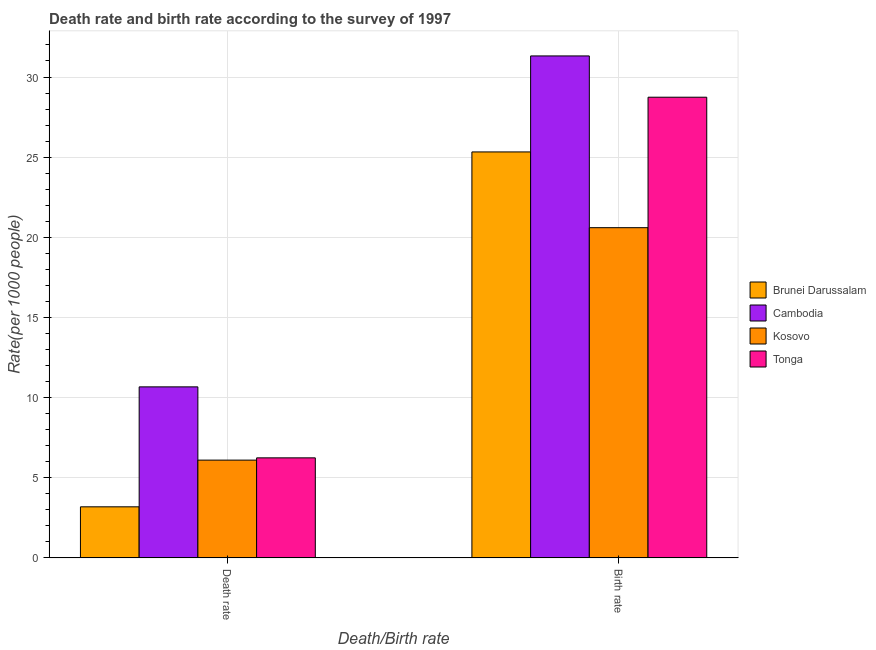Are the number of bars per tick equal to the number of legend labels?
Provide a succinct answer. Yes. What is the label of the 2nd group of bars from the left?
Offer a very short reply. Birth rate. What is the death rate in Brunei Darussalam?
Keep it short and to the point. 3.19. Across all countries, what is the maximum birth rate?
Your answer should be compact. 31.32. Across all countries, what is the minimum death rate?
Your answer should be very brief. 3.19. In which country was the death rate maximum?
Make the answer very short. Cambodia. In which country was the birth rate minimum?
Provide a short and direct response. Kosovo. What is the total death rate in the graph?
Keep it short and to the point. 26.2. What is the difference between the death rate in Tonga and that in Cambodia?
Offer a terse response. -4.43. What is the difference between the death rate in Tonga and the birth rate in Kosovo?
Your answer should be very brief. -14.36. What is the average death rate per country?
Offer a very short reply. 6.55. What is the difference between the death rate and birth rate in Cambodia?
Provide a short and direct response. -20.65. In how many countries, is the death rate greater than 13 ?
Keep it short and to the point. 0. What is the ratio of the birth rate in Cambodia to that in Brunei Darussalam?
Keep it short and to the point. 1.24. Is the birth rate in Kosovo less than that in Cambodia?
Your response must be concise. Yes. In how many countries, is the birth rate greater than the average birth rate taken over all countries?
Make the answer very short. 2. What does the 1st bar from the left in Death rate represents?
Ensure brevity in your answer.  Brunei Darussalam. What does the 3rd bar from the right in Death rate represents?
Give a very brief answer. Cambodia. How many bars are there?
Keep it short and to the point. 8. How many countries are there in the graph?
Your answer should be compact. 4. Does the graph contain any zero values?
Keep it short and to the point. No. Where does the legend appear in the graph?
Offer a very short reply. Center right. How many legend labels are there?
Give a very brief answer. 4. How are the legend labels stacked?
Ensure brevity in your answer.  Vertical. What is the title of the graph?
Keep it short and to the point. Death rate and birth rate according to the survey of 1997. What is the label or title of the X-axis?
Your response must be concise. Death/Birth rate. What is the label or title of the Y-axis?
Ensure brevity in your answer.  Rate(per 1000 people). What is the Rate(per 1000 people) of Brunei Darussalam in Death rate?
Provide a succinct answer. 3.19. What is the Rate(per 1000 people) in Cambodia in Death rate?
Offer a terse response. 10.67. What is the Rate(per 1000 people) of Tonga in Death rate?
Your answer should be very brief. 6.24. What is the Rate(per 1000 people) in Brunei Darussalam in Birth rate?
Your response must be concise. 25.33. What is the Rate(per 1000 people) in Cambodia in Birth rate?
Keep it short and to the point. 31.32. What is the Rate(per 1000 people) of Kosovo in Birth rate?
Keep it short and to the point. 20.6. What is the Rate(per 1000 people) in Tonga in Birth rate?
Your answer should be very brief. 28.74. Across all Death/Birth rate, what is the maximum Rate(per 1000 people) of Brunei Darussalam?
Ensure brevity in your answer.  25.33. Across all Death/Birth rate, what is the maximum Rate(per 1000 people) in Cambodia?
Offer a terse response. 31.32. Across all Death/Birth rate, what is the maximum Rate(per 1000 people) of Kosovo?
Provide a succinct answer. 20.6. Across all Death/Birth rate, what is the maximum Rate(per 1000 people) in Tonga?
Your answer should be very brief. 28.74. Across all Death/Birth rate, what is the minimum Rate(per 1000 people) in Brunei Darussalam?
Your answer should be very brief. 3.19. Across all Death/Birth rate, what is the minimum Rate(per 1000 people) of Cambodia?
Offer a very short reply. 10.67. Across all Death/Birth rate, what is the minimum Rate(per 1000 people) of Kosovo?
Your answer should be compact. 6.1. Across all Death/Birth rate, what is the minimum Rate(per 1000 people) of Tonga?
Ensure brevity in your answer.  6.24. What is the total Rate(per 1000 people) in Brunei Darussalam in the graph?
Provide a short and direct response. 28.51. What is the total Rate(per 1000 people) in Cambodia in the graph?
Your answer should be very brief. 41.98. What is the total Rate(per 1000 people) in Kosovo in the graph?
Give a very brief answer. 26.7. What is the total Rate(per 1000 people) of Tonga in the graph?
Make the answer very short. 34.98. What is the difference between the Rate(per 1000 people) in Brunei Darussalam in Death rate and that in Birth rate?
Make the answer very short. -22.14. What is the difference between the Rate(per 1000 people) of Cambodia in Death rate and that in Birth rate?
Give a very brief answer. -20.64. What is the difference between the Rate(per 1000 people) of Tonga in Death rate and that in Birth rate?
Offer a very short reply. -22.5. What is the difference between the Rate(per 1000 people) of Brunei Darussalam in Death rate and the Rate(per 1000 people) of Cambodia in Birth rate?
Your response must be concise. -28.13. What is the difference between the Rate(per 1000 people) of Brunei Darussalam in Death rate and the Rate(per 1000 people) of Kosovo in Birth rate?
Make the answer very short. -17.41. What is the difference between the Rate(per 1000 people) in Brunei Darussalam in Death rate and the Rate(per 1000 people) in Tonga in Birth rate?
Keep it short and to the point. -25.55. What is the difference between the Rate(per 1000 people) of Cambodia in Death rate and the Rate(per 1000 people) of Kosovo in Birth rate?
Your answer should be very brief. -9.93. What is the difference between the Rate(per 1000 people) of Cambodia in Death rate and the Rate(per 1000 people) of Tonga in Birth rate?
Your response must be concise. -18.07. What is the difference between the Rate(per 1000 people) of Kosovo in Death rate and the Rate(per 1000 people) of Tonga in Birth rate?
Offer a terse response. -22.64. What is the average Rate(per 1000 people) of Brunei Darussalam per Death/Birth rate?
Provide a short and direct response. 14.26. What is the average Rate(per 1000 people) of Cambodia per Death/Birth rate?
Provide a short and direct response. 20.99. What is the average Rate(per 1000 people) in Kosovo per Death/Birth rate?
Offer a very short reply. 13.35. What is the average Rate(per 1000 people) in Tonga per Death/Birth rate?
Your answer should be compact. 17.49. What is the difference between the Rate(per 1000 people) of Brunei Darussalam and Rate(per 1000 people) of Cambodia in Death rate?
Offer a very short reply. -7.48. What is the difference between the Rate(per 1000 people) of Brunei Darussalam and Rate(per 1000 people) of Kosovo in Death rate?
Provide a succinct answer. -2.91. What is the difference between the Rate(per 1000 people) of Brunei Darussalam and Rate(per 1000 people) of Tonga in Death rate?
Make the answer very short. -3.06. What is the difference between the Rate(per 1000 people) in Cambodia and Rate(per 1000 people) in Kosovo in Death rate?
Keep it short and to the point. 4.57. What is the difference between the Rate(per 1000 people) of Cambodia and Rate(per 1000 people) of Tonga in Death rate?
Offer a very short reply. 4.43. What is the difference between the Rate(per 1000 people) in Kosovo and Rate(per 1000 people) in Tonga in Death rate?
Keep it short and to the point. -0.14. What is the difference between the Rate(per 1000 people) in Brunei Darussalam and Rate(per 1000 people) in Cambodia in Birth rate?
Ensure brevity in your answer.  -5.99. What is the difference between the Rate(per 1000 people) of Brunei Darussalam and Rate(per 1000 people) of Kosovo in Birth rate?
Your answer should be compact. 4.73. What is the difference between the Rate(per 1000 people) of Brunei Darussalam and Rate(per 1000 people) of Tonga in Birth rate?
Provide a short and direct response. -3.41. What is the difference between the Rate(per 1000 people) in Cambodia and Rate(per 1000 people) in Kosovo in Birth rate?
Ensure brevity in your answer.  10.71. What is the difference between the Rate(per 1000 people) of Cambodia and Rate(per 1000 people) of Tonga in Birth rate?
Ensure brevity in your answer.  2.58. What is the difference between the Rate(per 1000 people) of Kosovo and Rate(per 1000 people) of Tonga in Birth rate?
Keep it short and to the point. -8.14. What is the ratio of the Rate(per 1000 people) of Brunei Darussalam in Death rate to that in Birth rate?
Keep it short and to the point. 0.13. What is the ratio of the Rate(per 1000 people) of Cambodia in Death rate to that in Birth rate?
Keep it short and to the point. 0.34. What is the ratio of the Rate(per 1000 people) of Kosovo in Death rate to that in Birth rate?
Keep it short and to the point. 0.3. What is the ratio of the Rate(per 1000 people) of Tonga in Death rate to that in Birth rate?
Offer a very short reply. 0.22. What is the difference between the highest and the second highest Rate(per 1000 people) in Brunei Darussalam?
Your answer should be compact. 22.14. What is the difference between the highest and the second highest Rate(per 1000 people) of Cambodia?
Keep it short and to the point. 20.64. What is the difference between the highest and the second highest Rate(per 1000 people) of Kosovo?
Your answer should be very brief. 14.5. What is the difference between the highest and the second highest Rate(per 1000 people) of Tonga?
Give a very brief answer. 22.5. What is the difference between the highest and the lowest Rate(per 1000 people) of Brunei Darussalam?
Provide a short and direct response. 22.14. What is the difference between the highest and the lowest Rate(per 1000 people) in Cambodia?
Ensure brevity in your answer.  20.64. What is the difference between the highest and the lowest Rate(per 1000 people) in Tonga?
Keep it short and to the point. 22.5. 